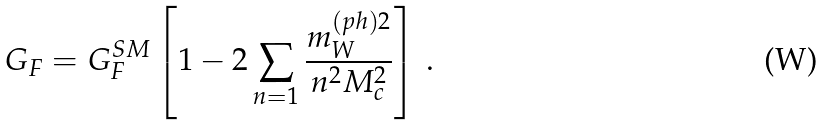Convert formula to latex. <formula><loc_0><loc_0><loc_500><loc_500>G _ { F } = G _ { F } ^ { S M } \left [ 1 - 2 \sum _ { n = 1 } \frac { m _ { W } ^ { ( p h ) 2 } } { n ^ { 2 } M _ { c } ^ { 2 } } \right ] \, .</formula> 